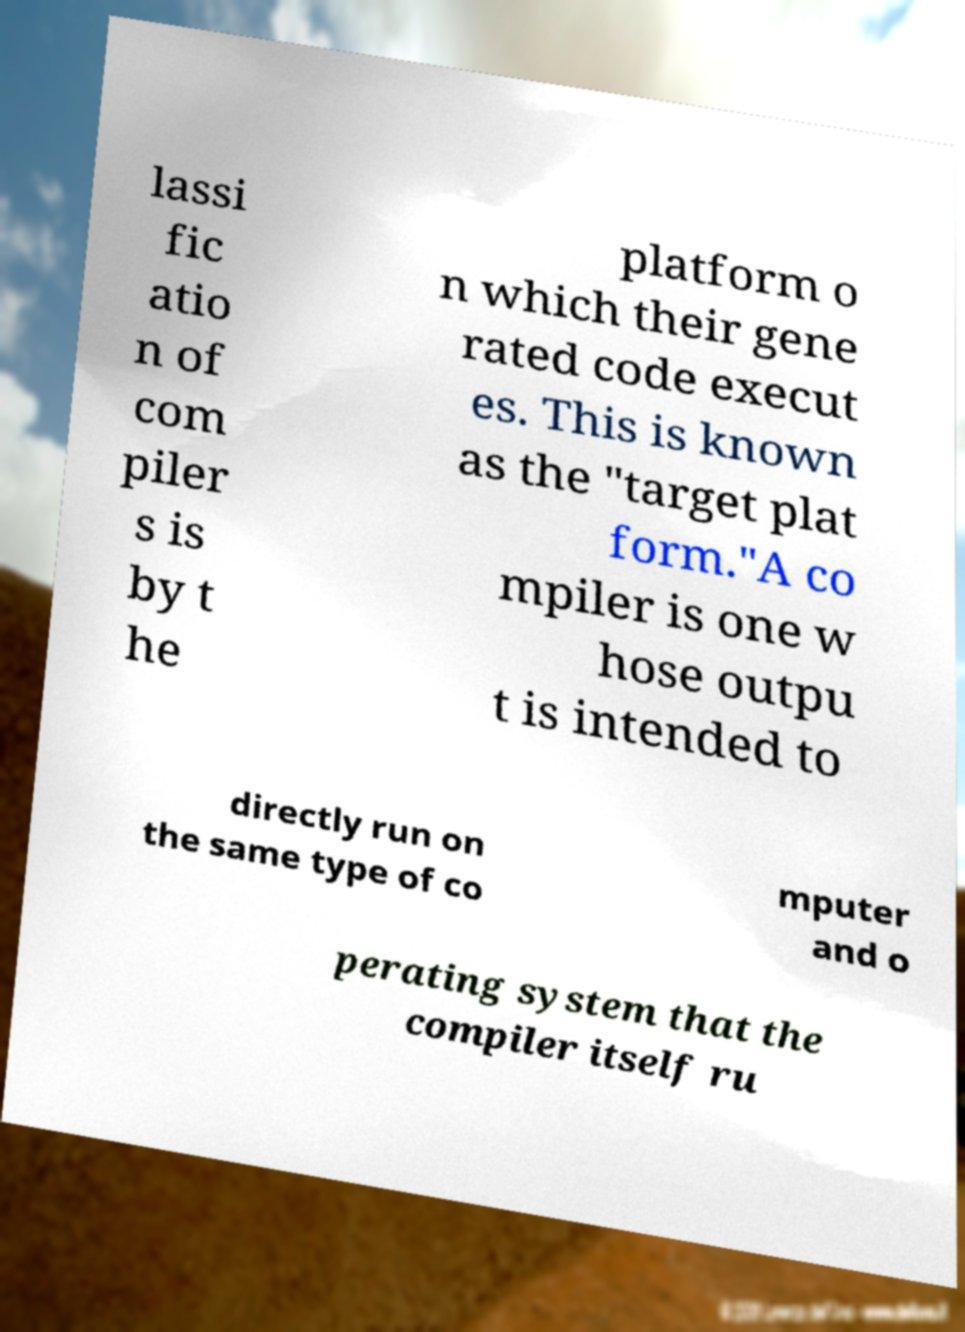For documentation purposes, I need the text within this image transcribed. Could you provide that? lassi fic atio n of com piler s is by t he platform o n which their gene rated code execut es. This is known as the "target plat form."A co mpiler is one w hose outpu t is intended to directly run on the same type of co mputer and o perating system that the compiler itself ru 